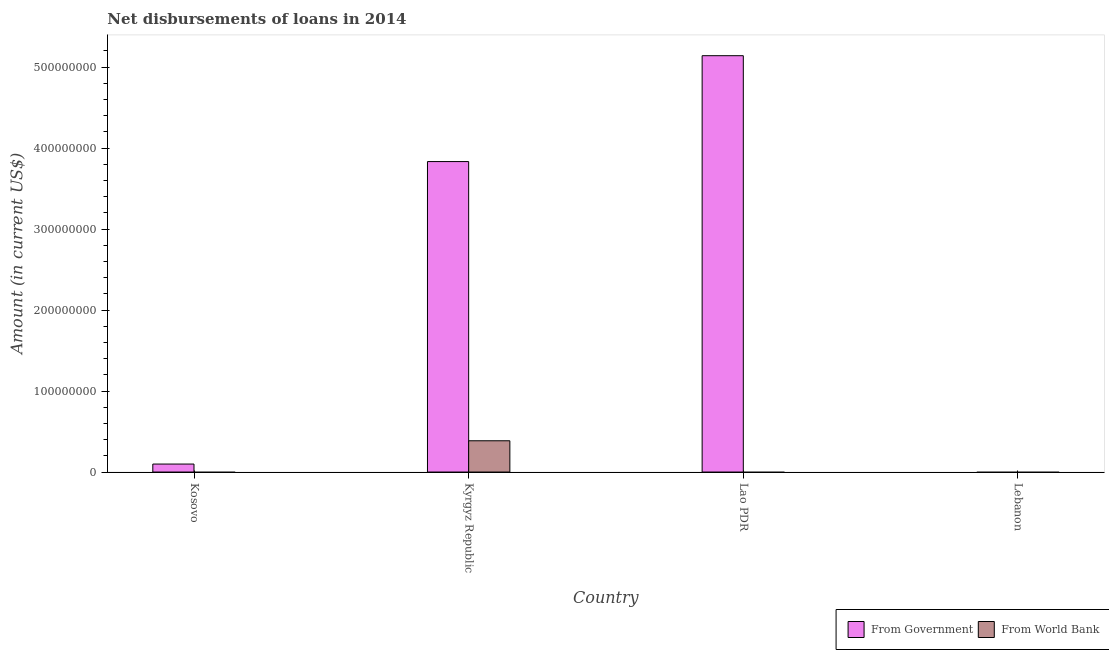How many different coloured bars are there?
Give a very brief answer. 2. Are the number of bars per tick equal to the number of legend labels?
Make the answer very short. No. Are the number of bars on each tick of the X-axis equal?
Your answer should be compact. No. How many bars are there on the 3rd tick from the right?
Ensure brevity in your answer.  2. What is the label of the 1st group of bars from the left?
Offer a terse response. Kosovo. In how many cases, is the number of bars for a given country not equal to the number of legend labels?
Ensure brevity in your answer.  3. What is the net disbursements of loan from government in Kosovo?
Your response must be concise. 9.84e+06. Across all countries, what is the maximum net disbursements of loan from government?
Your answer should be very brief. 5.14e+08. In which country was the net disbursements of loan from world bank maximum?
Keep it short and to the point. Kyrgyz Republic. What is the total net disbursements of loan from government in the graph?
Keep it short and to the point. 9.07e+08. What is the difference between the net disbursements of loan from government in Kosovo and that in Kyrgyz Republic?
Give a very brief answer. -3.73e+08. What is the difference between the net disbursements of loan from government in Lebanon and the net disbursements of loan from world bank in Lao PDR?
Offer a very short reply. 0. What is the average net disbursements of loan from government per country?
Your answer should be very brief. 2.27e+08. What is the difference between the net disbursements of loan from government and net disbursements of loan from world bank in Kyrgyz Republic?
Offer a very short reply. 3.45e+08. What is the ratio of the net disbursements of loan from government in Kosovo to that in Kyrgyz Republic?
Provide a succinct answer. 0.03. What is the difference between the highest and the second highest net disbursements of loan from government?
Your answer should be compact. 1.31e+08. What is the difference between the highest and the lowest net disbursements of loan from world bank?
Offer a very short reply. 3.86e+07. In how many countries, is the net disbursements of loan from world bank greater than the average net disbursements of loan from world bank taken over all countries?
Your answer should be compact. 1. How many countries are there in the graph?
Your answer should be compact. 4. What is the difference between two consecutive major ticks on the Y-axis?
Offer a very short reply. 1.00e+08. Are the values on the major ticks of Y-axis written in scientific E-notation?
Provide a succinct answer. No. Does the graph contain grids?
Ensure brevity in your answer.  No. How many legend labels are there?
Make the answer very short. 2. What is the title of the graph?
Provide a short and direct response. Net disbursements of loans in 2014. Does "Private creditors" appear as one of the legend labels in the graph?
Give a very brief answer. No. What is the label or title of the Y-axis?
Provide a short and direct response. Amount (in current US$). What is the Amount (in current US$) in From Government in Kosovo?
Give a very brief answer. 9.84e+06. What is the Amount (in current US$) in From World Bank in Kosovo?
Ensure brevity in your answer.  0. What is the Amount (in current US$) in From Government in Kyrgyz Republic?
Your answer should be compact. 3.83e+08. What is the Amount (in current US$) in From World Bank in Kyrgyz Republic?
Keep it short and to the point. 3.86e+07. What is the Amount (in current US$) of From Government in Lao PDR?
Ensure brevity in your answer.  5.14e+08. What is the Amount (in current US$) of From World Bank in Lao PDR?
Give a very brief answer. 0. What is the Amount (in current US$) of From World Bank in Lebanon?
Give a very brief answer. 0. Across all countries, what is the maximum Amount (in current US$) in From Government?
Your answer should be compact. 5.14e+08. Across all countries, what is the maximum Amount (in current US$) of From World Bank?
Your answer should be compact. 3.86e+07. Across all countries, what is the minimum Amount (in current US$) of From Government?
Provide a short and direct response. 0. What is the total Amount (in current US$) in From Government in the graph?
Keep it short and to the point. 9.07e+08. What is the total Amount (in current US$) in From World Bank in the graph?
Keep it short and to the point. 3.86e+07. What is the difference between the Amount (in current US$) in From Government in Kosovo and that in Kyrgyz Republic?
Your answer should be compact. -3.73e+08. What is the difference between the Amount (in current US$) in From Government in Kosovo and that in Lao PDR?
Give a very brief answer. -5.04e+08. What is the difference between the Amount (in current US$) in From Government in Kyrgyz Republic and that in Lao PDR?
Make the answer very short. -1.31e+08. What is the difference between the Amount (in current US$) of From Government in Kosovo and the Amount (in current US$) of From World Bank in Kyrgyz Republic?
Your answer should be very brief. -2.88e+07. What is the average Amount (in current US$) in From Government per country?
Ensure brevity in your answer.  2.27e+08. What is the average Amount (in current US$) of From World Bank per country?
Provide a succinct answer. 9.65e+06. What is the difference between the Amount (in current US$) in From Government and Amount (in current US$) in From World Bank in Kyrgyz Republic?
Keep it short and to the point. 3.45e+08. What is the ratio of the Amount (in current US$) of From Government in Kosovo to that in Kyrgyz Republic?
Offer a very short reply. 0.03. What is the ratio of the Amount (in current US$) of From Government in Kosovo to that in Lao PDR?
Your answer should be very brief. 0.02. What is the ratio of the Amount (in current US$) in From Government in Kyrgyz Republic to that in Lao PDR?
Make the answer very short. 0.75. What is the difference between the highest and the second highest Amount (in current US$) of From Government?
Offer a very short reply. 1.31e+08. What is the difference between the highest and the lowest Amount (in current US$) in From Government?
Your response must be concise. 5.14e+08. What is the difference between the highest and the lowest Amount (in current US$) of From World Bank?
Keep it short and to the point. 3.86e+07. 